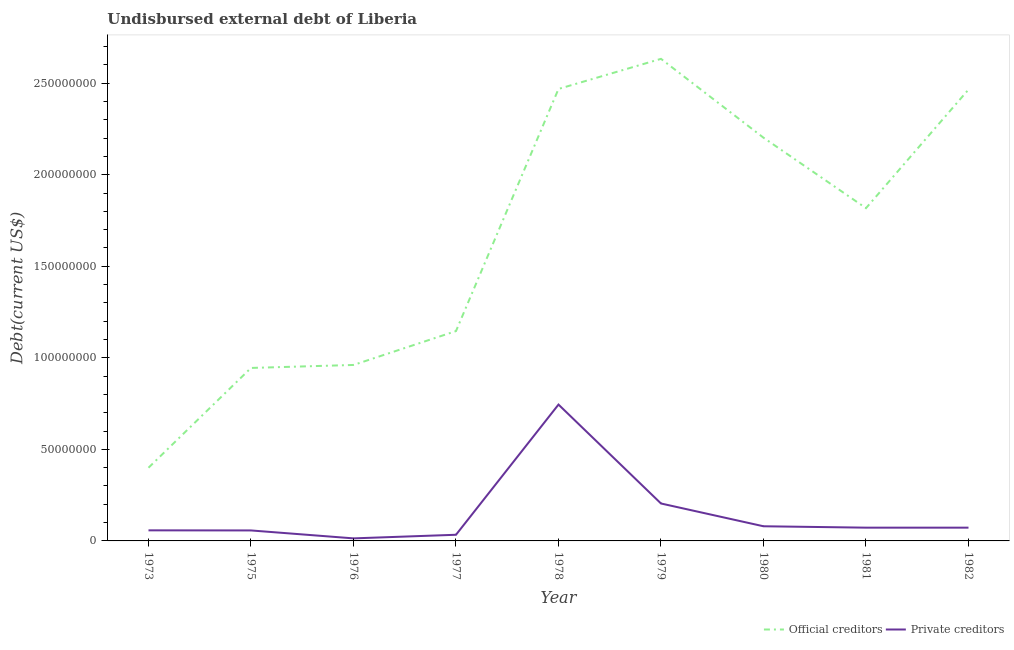How many different coloured lines are there?
Make the answer very short. 2. Does the line corresponding to undisbursed external debt of private creditors intersect with the line corresponding to undisbursed external debt of official creditors?
Ensure brevity in your answer.  No. Is the number of lines equal to the number of legend labels?
Provide a succinct answer. Yes. What is the undisbursed external debt of private creditors in 1981?
Your answer should be very brief. 7.24e+06. Across all years, what is the maximum undisbursed external debt of official creditors?
Your answer should be very brief. 2.63e+08. Across all years, what is the minimum undisbursed external debt of official creditors?
Provide a short and direct response. 4.00e+07. In which year was the undisbursed external debt of official creditors maximum?
Ensure brevity in your answer.  1979. In which year was the undisbursed external debt of private creditors minimum?
Keep it short and to the point. 1976. What is the total undisbursed external debt of private creditors in the graph?
Your answer should be very brief. 1.34e+08. What is the difference between the undisbursed external debt of private creditors in 1978 and that in 1982?
Provide a short and direct response. 6.72e+07. What is the difference between the undisbursed external debt of private creditors in 1981 and the undisbursed external debt of official creditors in 1977?
Ensure brevity in your answer.  -1.07e+08. What is the average undisbursed external debt of official creditors per year?
Your response must be concise. 1.67e+08. In the year 1982, what is the difference between the undisbursed external debt of private creditors and undisbursed external debt of official creditors?
Your answer should be compact. -2.39e+08. In how many years, is the undisbursed external debt of official creditors greater than 100000000 US$?
Make the answer very short. 6. What is the ratio of the undisbursed external debt of official creditors in 1979 to that in 1982?
Your answer should be very brief. 1.07. Is the difference between the undisbursed external debt of official creditors in 1977 and 1981 greater than the difference between the undisbursed external debt of private creditors in 1977 and 1981?
Keep it short and to the point. No. What is the difference between the highest and the second highest undisbursed external debt of private creditors?
Give a very brief answer. 5.40e+07. What is the difference between the highest and the lowest undisbursed external debt of private creditors?
Your answer should be very brief. 7.31e+07. Is the sum of the undisbursed external debt of official creditors in 1975 and 1977 greater than the maximum undisbursed external debt of private creditors across all years?
Ensure brevity in your answer.  Yes. Does the undisbursed external debt of private creditors monotonically increase over the years?
Offer a very short reply. No. Is the undisbursed external debt of official creditors strictly less than the undisbursed external debt of private creditors over the years?
Make the answer very short. No. How many years are there in the graph?
Offer a terse response. 9. What is the difference between two consecutive major ticks on the Y-axis?
Ensure brevity in your answer.  5.00e+07. Does the graph contain grids?
Make the answer very short. No. Where does the legend appear in the graph?
Your answer should be very brief. Bottom right. How many legend labels are there?
Provide a succinct answer. 2. What is the title of the graph?
Provide a short and direct response. Undisbursed external debt of Liberia. What is the label or title of the X-axis?
Keep it short and to the point. Year. What is the label or title of the Y-axis?
Offer a very short reply. Debt(current US$). What is the Debt(current US$) of Official creditors in 1973?
Offer a terse response. 4.00e+07. What is the Debt(current US$) in Private creditors in 1973?
Ensure brevity in your answer.  5.78e+06. What is the Debt(current US$) in Official creditors in 1975?
Your answer should be compact. 9.45e+07. What is the Debt(current US$) of Private creditors in 1975?
Provide a short and direct response. 5.72e+06. What is the Debt(current US$) in Official creditors in 1976?
Your response must be concise. 9.61e+07. What is the Debt(current US$) in Private creditors in 1976?
Offer a terse response. 1.39e+06. What is the Debt(current US$) of Official creditors in 1977?
Make the answer very short. 1.15e+08. What is the Debt(current US$) in Private creditors in 1977?
Provide a short and direct response. 3.36e+06. What is the Debt(current US$) in Official creditors in 1978?
Your answer should be compact. 2.47e+08. What is the Debt(current US$) of Private creditors in 1978?
Make the answer very short. 7.45e+07. What is the Debt(current US$) of Official creditors in 1979?
Ensure brevity in your answer.  2.63e+08. What is the Debt(current US$) in Private creditors in 1979?
Your answer should be very brief. 2.04e+07. What is the Debt(current US$) of Official creditors in 1980?
Make the answer very short. 2.20e+08. What is the Debt(current US$) of Official creditors in 1981?
Ensure brevity in your answer.  1.82e+08. What is the Debt(current US$) in Private creditors in 1981?
Offer a very short reply. 7.24e+06. What is the Debt(current US$) of Official creditors in 1982?
Provide a short and direct response. 2.46e+08. What is the Debt(current US$) in Private creditors in 1982?
Give a very brief answer. 7.24e+06. Across all years, what is the maximum Debt(current US$) in Official creditors?
Ensure brevity in your answer.  2.63e+08. Across all years, what is the maximum Debt(current US$) in Private creditors?
Offer a very short reply. 7.45e+07. Across all years, what is the minimum Debt(current US$) of Official creditors?
Make the answer very short. 4.00e+07. Across all years, what is the minimum Debt(current US$) of Private creditors?
Your answer should be very brief. 1.39e+06. What is the total Debt(current US$) of Official creditors in the graph?
Offer a very short reply. 1.50e+09. What is the total Debt(current US$) in Private creditors in the graph?
Provide a succinct answer. 1.34e+08. What is the difference between the Debt(current US$) of Official creditors in 1973 and that in 1975?
Provide a succinct answer. -5.45e+07. What is the difference between the Debt(current US$) in Private creditors in 1973 and that in 1975?
Your answer should be very brief. 5.30e+04. What is the difference between the Debt(current US$) of Official creditors in 1973 and that in 1976?
Offer a very short reply. -5.61e+07. What is the difference between the Debt(current US$) of Private creditors in 1973 and that in 1976?
Offer a terse response. 4.38e+06. What is the difference between the Debt(current US$) of Official creditors in 1973 and that in 1977?
Give a very brief answer. -7.46e+07. What is the difference between the Debt(current US$) in Private creditors in 1973 and that in 1977?
Provide a short and direct response. 2.42e+06. What is the difference between the Debt(current US$) of Official creditors in 1973 and that in 1978?
Keep it short and to the point. -2.07e+08. What is the difference between the Debt(current US$) of Private creditors in 1973 and that in 1978?
Your answer should be very brief. -6.87e+07. What is the difference between the Debt(current US$) of Official creditors in 1973 and that in 1979?
Offer a very short reply. -2.23e+08. What is the difference between the Debt(current US$) in Private creditors in 1973 and that in 1979?
Provide a succinct answer. -1.47e+07. What is the difference between the Debt(current US$) of Official creditors in 1973 and that in 1980?
Offer a terse response. -1.80e+08. What is the difference between the Debt(current US$) of Private creditors in 1973 and that in 1980?
Offer a very short reply. -2.22e+06. What is the difference between the Debt(current US$) of Official creditors in 1973 and that in 1981?
Your answer should be compact. -1.42e+08. What is the difference between the Debt(current US$) in Private creditors in 1973 and that in 1981?
Your answer should be very brief. -1.47e+06. What is the difference between the Debt(current US$) in Official creditors in 1973 and that in 1982?
Your response must be concise. -2.07e+08. What is the difference between the Debt(current US$) of Private creditors in 1973 and that in 1982?
Provide a short and direct response. -1.47e+06. What is the difference between the Debt(current US$) in Official creditors in 1975 and that in 1976?
Make the answer very short. -1.63e+06. What is the difference between the Debt(current US$) of Private creditors in 1975 and that in 1976?
Your response must be concise. 4.33e+06. What is the difference between the Debt(current US$) of Official creditors in 1975 and that in 1977?
Your response must be concise. -2.01e+07. What is the difference between the Debt(current US$) in Private creditors in 1975 and that in 1977?
Offer a very short reply. 2.36e+06. What is the difference between the Debt(current US$) in Official creditors in 1975 and that in 1978?
Make the answer very short. -1.52e+08. What is the difference between the Debt(current US$) of Private creditors in 1975 and that in 1978?
Give a very brief answer. -6.87e+07. What is the difference between the Debt(current US$) in Official creditors in 1975 and that in 1979?
Make the answer very short. -1.69e+08. What is the difference between the Debt(current US$) in Private creditors in 1975 and that in 1979?
Your answer should be compact. -1.47e+07. What is the difference between the Debt(current US$) of Official creditors in 1975 and that in 1980?
Provide a succinct answer. -1.26e+08. What is the difference between the Debt(current US$) in Private creditors in 1975 and that in 1980?
Make the answer very short. -2.28e+06. What is the difference between the Debt(current US$) in Official creditors in 1975 and that in 1981?
Your response must be concise. -8.73e+07. What is the difference between the Debt(current US$) in Private creditors in 1975 and that in 1981?
Your response must be concise. -1.52e+06. What is the difference between the Debt(current US$) in Official creditors in 1975 and that in 1982?
Your answer should be very brief. -1.52e+08. What is the difference between the Debt(current US$) of Private creditors in 1975 and that in 1982?
Provide a short and direct response. -1.52e+06. What is the difference between the Debt(current US$) in Official creditors in 1976 and that in 1977?
Ensure brevity in your answer.  -1.85e+07. What is the difference between the Debt(current US$) of Private creditors in 1976 and that in 1977?
Offer a terse response. -1.97e+06. What is the difference between the Debt(current US$) in Official creditors in 1976 and that in 1978?
Your answer should be compact. -1.51e+08. What is the difference between the Debt(current US$) in Private creditors in 1976 and that in 1978?
Keep it short and to the point. -7.31e+07. What is the difference between the Debt(current US$) of Official creditors in 1976 and that in 1979?
Keep it short and to the point. -1.67e+08. What is the difference between the Debt(current US$) of Private creditors in 1976 and that in 1979?
Give a very brief answer. -1.90e+07. What is the difference between the Debt(current US$) of Official creditors in 1976 and that in 1980?
Your answer should be compact. -1.24e+08. What is the difference between the Debt(current US$) in Private creditors in 1976 and that in 1980?
Your answer should be very brief. -6.61e+06. What is the difference between the Debt(current US$) in Official creditors in 1976 and that in 1981?
Your answer should be compact. -8.56e+07. What is the difference between the Debt(current US$) of Private creditors in 1976 and that in 1981?
Your answer should be compact. -5.85e+06. What is the difference between the Debt(current US$) of Official creditors in 1976 and that in 1982?
Provide a succinct answer. -1.50e+08. What is the difference between the Debt(current US$) of Private creditors in 1976 and that in 1982?
Your response must be concise. -5.85e+06. What is the difference between the Debt(current US$) in Official creditors in 1977 and that in 1978?
Your answer should be compact. -1.32e+08. What is the difference between the Debt(current US$) in Private creditors in 1977 and that in 1978?
Offer a terse response. -7.11e+07. What is the difference between the Debt(current US$) of Official creditors in 1977 and that in 1979?
Keep it short and to the point. -1.49e+08. What is the difference between the Debt(current US$) of Private creditors in 1977 and that in 1979?
Provide a succinct answer. -1.71e+07. What is the difference between the Debt(current US$) in Official creditors in 1977 and that in 1980?
Provide a short and direct response. -1.06e+08. What is the difference between the Debt(current US$) in Private creditors in 1977 and that in 1980?
Give a very brief answer. -4.64e+06. What is the difference between the Debt(current US$) in Official creditors in 1977 and that in 1981?
Make the answer very short. -6.71e+07. What is the difference between the Debt(current US$) of Private creditors in 1977 and that in 1981?
Provide a short and direct response. -3.88e+06. What is the difference between the Debt(current US$) of Official creditors in 1977 and that in 1982?
Make the answer very short. -1.32e+08. What is the difference between the Debt(current US$) in Private creditors in 1977 and that in 1982?
Your answer should be very brief. -3.88e+06. What is the difference between the Debt(current US$) of Official creditors in 1978 and that in 1979?
Ensure brevity in your answer.  -1.64e+07. What is the difference between the Debt(current US$) in Private creditors in 1978 and that in 1979?
Provide a succinct answer. 5.40e+07. What is the difference between the Debt(current US$) of Official creditors in 1978 and that in 1980?
Your answer should be compact. 2.66e+07. What is the difference between the Debt(current US$) of Private creditors in 1978 and that in 1980?
Your answer should be very brief. 6.65e+07. What is the difference between the Debt(current US$) in Official creditors in 1978 and that in 1981?
Provide a short and direct response. 6.51e+07. What is the difference between the Debt(current US$) of Private creditors in 1978 and that in 1981?
Your answer should be very brief. 6.72e+07. What is the difference between the Debt(current US$) in Official creditors in 1978 and that in 1982?
Provide a succinct answer. 3.36e+05. What is the difference between the Debt(current US$) of Private creditors in 1978 and that in 1982?
Your response must be concise. 6.72e+07. What is the difference between the Debt(current US$) of Official creditors in 1979 and that in 1980?
Your response must be concise. 4.31e+07. What is the difference between the Debt(current US$) in Private creditors in 1979 and that in 1980?
Provide a short and direct response. 1.24e+07. What is the difference between the Debt(current US$) in Official creditors in 1979 and that in 1981?
Provide a succinct answer. 8.15e+07. What is the difference between the Debt(current US$) in Private creditors in 1979 and that in 1981?
Offer a terse response. 1.32e+07. What is the difference between the Debt(current US$) in Official creditors in 1979 and that in 1982?
Provide a short and direct response. 1.68e+07. What is the difference between the Debt(current US$) of Private creditors in 1979 and that in 1982?
Offer a very short reply. 1.32e+07. What is the difference between the Debt(current US$) in Official creditors in 1980 and that in 1981?
Offer a terse response. 3.85e+07. What is the difference between the Debt(current US$) of Private creditors in 1980 and that in 1981?
Provide a short and direct response. 7.58e+05. What is the difference between the Debt(current US$) of Official creditors in 1980 and that in 1982?
Make the answer very short. -2.63e+07. What is the difference between the Debt(current US$) in Private creditors in 1980 and that in 1982?
Ensure brevity in your answer.  7.58e+05. What is the difference between the Debt(current US$) in Official creditors in 1981 and that in 1982?
Your response must be concise. -6.48e+07. What is the difference between the Debt(current US$) of Official creditors in 1973 and the Debt(current US$) of Private creditors in 1975?
Ensure brevity in your answer.  3.42e+07. What is the difference between the Debt(current US$) of Official creditors in 1973 and the Debt(current US$) of Private creditors in 1976?
Provide a succinct answer. 3.86e+07. What is the difference between the Debt(current US$) of Official creditors in 1973 and the Debt(current US$) of Private creditors in 1977?
Offer a terse response. 3.66e+07. What is the difference between the Debt(current US$) of Official creditors in 1973 and the Debt(current US$) of Private creditors in 1978?
Provide a succinct answer. -3.45e+07. What is the difference between the Debt(current US$) in Official creditors in 1973 and the Debt(current US$) in Private creditors in 1979?
Your answer should be compact. 1.95e+07. What is the difference between the Debt(current US$) in Official creditors in 1973 and the Debt(current US$) in Private creditors in 1980?
Give a very brief answer. 3.20e+07. What is the difference between the Debt(current US$) of Official creditors in 1973 and the Debt(current US$) of Private creditors in 1981?
Your response must be concise. 3.27e+07. What is the difference between the Debt(current US$) of Official creditors in 1973 and the Debt(current US$) of Private creditors in 1982?
Provide a succinct answer. 3.27e+07. What is the difference between the Debt(current US$) of Official creditors in 1975 and the Debt(current US$) of Private creditors in 1976?
Your response must be concise. 9.31e+07. What is the difference between the Debt(current US$) in Official creditors in 1975 and the Debt(current US$) in Private creditors in 1977?
Ensure brevity in your answer.  9.11e+07. What is the difference between the Debt(current US$) of Official creditors in 1975 and the Debt(current US$) of Private creditors in 1978?
Make the answer very short. 2.00e+07. What is the difference between the Debt(current US$) of Official creditors in 1975 and the Debt(current US$) of Private creditors in 1979?
Your answer should be very brief. 7.40e+07. What is the difference between the Debt(current US$) in Official creditors in 1975 and the Debt(current US$) in Private creditors in 1980?
Offer a very short reply. 8.65e+07. What is the difference between the Debt(current US$) in Official creditors in 1975 and the Debt(current US$) in Private creditors in 1981?
Provide a short and direct response. 8.72e+07. What is the difference between the Debt(current US$) in Official creditors in 1975 and the Debt(current US$) in Private creditors in 1982?
Your answer should be compact. 8.72e+07. What is the difference between the Debt(current US$) in Official creditors in 1976 and the Debt(current US$) in Private creditors in 1977?
Your answer should be compact. 9.27e+07. What is the difference between the Debt(current US$) in Official creditors in 1976 and the Debt(current US$) in Private creditors in 1978?
Offer a very short reply. 2.16e+07. What is the difference between the Debt(current US$) in Official creditors in 1976 and the Debt(current US$) in Private creditors in 1979?
Ensure brevity in your answer.  7.57e+07. What is the difference between the Debt(current US$) in Official creditors in 1976 and the Debt(current US$) in Private creditors in 1980?
Offer a very short reply. 8.81e+07. What is the difference between the Debt(current US$) of Official creditors in 1976 and the Debt(current US$) of Private creditors in 1981?
Your answer should be compact. 8.89e+07. What is the difference between the Debt(current US$) of Official creditors in 1976 and the Debt(current US$) of Private creditors in 1982?
Your answer should be compact. 8.89e+07. What is the difference between the Debt(current US$) of Official creditors in 1977 and the Debt(current US$) of Private creditors in 1978?
Ensure brevity in your answer.  4.01e+07. What is the difference between the Debt(current US$) in Official creditors in 1977 and the Debt(current US$) in Private creditors in 1979?
Your answer should be compact. 9.42e+07. What is the difference between the Debt(current US$) of Official creditors in 1977 and the Debt(current US$) of Private creditors in 1980?
Provide a succinct answer. 1.07e+08. What is the difference between the Debt(current US$) of Official creditors in 1977 and the Debt(current US$) of Private creditors in 1981?
Your answer should be very brief. 1.07e+08. What is the difference between the Debt(current US$) of Official creditors in 1977 and the Debt(current US$) of Private creditors in 1982?
Provide a succinct answer. 1.07e+08. What is the difference between the Debt(current US$) in Official creditors in 1978 and the Debt(current US$) in Private creditors in 1979?
Offer a very short reply. 2.26e+08. What is the difference between the Debt(current US$) in Official creditors in 1978 and the Debt(current US$) in Private creditors in 1980?
Offer a very short reply. 2.39e+08. What is the difference between the Debt(current US$) in Official creditors in 1978 and the Debt(current US$) in Private creditors in 1981?
Provide a short and direct response. 2.40e+08. What is the difference between the Debt(current US$) of Official creditors in 1978 and the Debt(current US$) of Private creditors in 1982?
Ensure brevity in your answer.  2.40e+08. What is the difference between the Debt(current US$) of Official creditors in 1979 and the Debt(current US$) of Private creditors in 1980?
Offer a terse response. 2.55e+08. What is the difference between the Debt(current US$) in Official creditors in 1979 and the Debt(current US$) in Private creditors in 1981?
Give a very brief answer. 2.56e+08. What is the difference between the Debt(current US$) of Official creditors in 1979 and the Debt(current US$) of Private creditors in 1982?
Keep it short and to the point. 2.56e+08. What is the difference between the Debt(current US$) in Official creditors in 1980 and the Debt(current US$) in Private creditors in 1981?
Keep it short and to the point. 2.13e+08. What is the difference between the Debt(current US$) in Official creditors in 1980 and the Debt(current US$) in Private creditors in 1982?
Your answer should be very brief. 2.13e+08. What is the difference between the Debt(current US$) in Official creditors in 1981 and the Debt(current US$) in Private creditors in 1982?
Provide a short and direct response. 1.74e+08. What is the average Debt(current US$) in Official creditors per year?
Make the answer very short. 1.67e+08. What is the average Debt(current US$) of Private creditors per year?
Ensure brevity in your answer.  1.48e+07. In the year 1973, what is the difference between the Debt(current US$) of Official creditors and Debt(current US$) of Private creditors?
Ensure brevity in your answer.  3.42e+07. In the year 1975, what is the difference between the Debt(current US$) in Official creditors and Debt(current US$) in Private creditors?
Ensure brevity in your answer.  8.87e+07. In the year 1976, what is the difference between the Debt(current US$) of Official creditors and Debt(current US$) of Private creditors?
Keep it short and to the point. 9.47e+07. In the year 1977, what is the difference between the Debt(current US$) of Official creditors and Debt(current US$) of Private creditors?
Your response must be concise. 1.11e+08. In the year 1978, what is the difference between the Debt(current US$) in Official creditors and Debt(current US$) in Private creditors?
Offer a very short reply. 1.72e+08. In the year 1979, what is the difference between the Debt(current US$) in Official creditors and Debt(current US$) in Private creditors?
Offer a very short reply. 2.43e+08. In the year 1980, what is the difference between the Debt(current US$) in Official creditors and Debt(current US$) in Private creditors?
Offer a terse response. 2.12e+08. In the year 1981, what is the difference between the Debt(current US$) in Official creditors and Debt(current US$) in Private creditors?
Keep it short and to the point. 1.74e+08. In the year 1982, what is the difference between the Debt(current US$) of Official creditors and Debt(current US$) of Private creditors?
Your response must be concise. 2.39e+08. What is the ratio of the Debt(current US$) of Official creditors in 1973 to that in 1975?
Your answer should be compact. 0.42. What is the ratio of the Debt(current US$) in Private creditors in 1973 to that in 1975?
Your answer should be very brief. 1.01. What is the ratio of the Debt(current US$) in Official creditors in 1973 to that in 1976?
Provide a short and direct response. 0.42. What is the ratio of the Debt(current US$) in Private creditors in 1973 to that in 1976?
Offer a very short reply. 4.15. What is the ratio of the Debt(current US$) in Official creditors in 1973 to that in 1977?
Make the answer very short. 0.35. What is the ratio of the Debt(current US$) of Private creditors in 1973 to that in 1977?
Give a very brief answer. 1.72. What is the ratio of the Debt(current US$) of Official creditors in 1973 to that in 1978?
Offer a very short reply. 0.16. What is the ratio of the Debt(current US$) of Private creditors in 1973 to that in 1978?
Your answer should be very brief. 0.08. What is the ratio of the Debt(current US$) of Official creditors in 1973 to that in 1979?
Give a very brief answer. 0.15. What is the ratio of the Debt(current US$) of Private creditors in 1973 to that in 1979?
Keep it short and to the point. 0.28. What is the ratio of the Debt(current US$) in Official creditors in 1973 to that in 1980?
Give a very brief answer. 0.18. What is the ratio of the Debt(current US$) of Private creditors in 1973 to that in 1980?
Provide a short and direct response. 0.72. What is the ratio of the Debt(current US$) of Official creditors in 1973 to that in 1981?
Give a very brief answer. 0.22. What is the ratio of the Debt(current US$) of Private creditors in 1973 to that in 1981?
Your response must be concise. 0.8. What is the ratio of the Debt(current US$) in Official creditors in 1973 to that in 1982?
Your answer should be very brief. 0.16. What is the ratio of the Debt(current US$) of Private creditors in 1973 to that in 1982?
Provide a short and direct response. 0.8. What is the ratio of the Debt(current US$) in Official creditors in 1975 to that in 1976?
Your answer should be compact. 0.98. What is the ratio of the Debt(current US$) in Private creditors in 1975 to that in 1976?
Keep it short and to the point. 4.11. What is the ratio of the Debt(current US$) of Official creditors in 1975 to that in 1977?
Your answer should be compact. 0.82. What is the ratio of the Debt(current US$) of Private creditors in 1975 to that in 1977?
Give a very brief answer. 1.7. What is the ratio of the Debt(current US$) in Official creditors in 1975 to that in 1978?
Provide a short and direct response. 0.38. What is the ratio of the Debt(current US$) of Private creditors in 1975 to that in 1978?
Provide a short and direct response. 0.08. What is the ratio of the Debt(current US$) of Official creditors in 1975 to that in 1979?
Provide a succinct answer. 0.36. What is the ratio of the Debt(current US$) of Private creditors in 1975 to that in 1979?
Ensure brevity in your answer.  0.28. What is the ratio of the Debt(current US$) in Official creditors in 1975 to that in 1980?
Your answer should be compact. 0.43. What is the ratio of the Debt(current US$) in Private creditors in 1975 to that in 1980?
Give a very brief answer. 0.72. What is the ratio of the Debt(current US$) in Official creditors in 1975 to that in 1981?
Provide a short and direct response. 0.52. What is the ratio of the Debt(current US$) of Private creditors in 1975 to that in 1981?
Offer a very short reply. 0.79. What is the ratio of the Debt(current US$) of Official creditors in 1975 to that in 1982?
Your answer should be compact. 0.38. What is the ratio of the Debt(current US$) in Private creditors in 1975 to that in 1982?
Ensure brevity in your answer.  0.79. What is the ratio of the Debt(current US$) in Official creditors in 1976 to that in 1977?
Ensure brevity in your answer.  0.84. What is the ratio of the Debt(current US$) in Private creditors in 1976 to that in 1977?
Your answer should be compact. 0.41. What is the ratio of the Debt(current US$) in Official creditors in 1976 to that in 1978?
Keep it short and to the point. 0.39. What is the ratio of the Debt(current US$) in Private creditors in 1976 to that in 1978?
Provide a short and direct response. 0.02. What is the ratio of the Debt(current US$) of Official creditors in 1976 to that in 1979?
Offer a terse response. 0.36. What is the ratio of the Debt(current US$) of Private creditors in 1976 to that in 1979?
Your answer should be compact. 0.07. What is the ratio of the Debt(current US$) of Official creditors in 1976 to that in 1980?
Offer a very short reply. 0.44. What is the ratio of the Debt(current US$) of Private creditors in 1976 to that in 1980?
Keep it short and to the point. 0.17. What is the ratio of the Debt(current US$) in Official creditors in 1976 to that in 1981?
Keep it short and to the point. 0.53. What is the ratio of the Debt(current US$) in Private creditors in 1976 to that in 1981?
Make the answer very short. 0.19. What is the ratio of the Debt(current US$) of Official creditors in 1976 to that in 1982?
Ensure brevity in your answer.  0.39. What is the ratio of the Debt(current US$) in Private creditors in 1976 to that in 1982?
Give a very brief answer. 0.19. What is the ratio of the Debt(current US$) of Official creditors in 1977 to that in 1978?
Make the answer very short. 0.46. What is the ratio of the Debt(current US$) of Private creditors in 1977 to that in 1978?
Give a very brief answer. 0.05. What is the ratio of the Debt(current US$) in Official creditors in 1977 to that in 1979?
Your response must be concise. 0.44. What is the ratio of the Debt(current US$) of Private creditors in 1977 to that in 1979?
Keep it short and to the point. 0.16. What is the ratio of the Debt(current US$) of Official creditors in 1977 to that in 1980?
Provide a succinct answer. 0.52. What is the ratio of the Debt(current US$) of Private creditors in 1977 to that in 1980?
Ensure brevity in your answer.  0.42. What is the ratio of the Debt(current US$) of Official creditors in 1977 to that in 1981?
Give a very brief answer. 0.63. What is the ratio of the Debt(current US$) in Private creditors in 1977 to that in 1981?
Offer a terse response. 0.46. What is the ratio of the Debt(current US$) in Official creditors in 1977 to that in 1982?
Provide a succinct answer. 0.46. What is the ratio of the Debt(current US$) of Private creditors in 1977 to that in 1982?
Offer a very short reply. 0.46. What is the ratio of the Debt(current US$) in Official creditors in 1978 to that in 1979?
Ensure brevity in your answer.  0.94. What is the ratio of the Debt(current US$) in Private creditors in 1978 to that in 1979?
Offer a very short reply. 3.64. What is the ratio of the Debt(current US$) in Official creditors in 1978 to that in 1980?
Make the answer very short. 1.12. What is the ratio of the Debt(current US$) in Private creditors in 1978 to that in 1980?
Your response must be concise. 9.31. What is the ratio of the Debt(current US$) of Official creditors in 1978 to that in 1981?
Offer a very short reply. 1.36. What is the ratio of the Debt(current US$) of Private creditors in 1978 to that in 1981?
Your response must be concise. 10.28. What is the ratio of the Debt(current US$) of Official creditors in 1978 to that in 1982?
Give a very brief answer. 1. What is the ratio of the Debt(current US$) of Private creditors in 1978 to that in 1982?
Offer a terse response. 10.28. What is the ratio of the Debt(current US$) of Official creditors in 1979 to that in 1980?
Offer a terse response. 1.2. What is the ratio of the Debt(current US$) of Private creditors in 1979 to that in 1980?
Ensure brevity in your answer.  2.55. What is the ratio of the Debt(current US$) of Official creditors in 1979 to that in 1981?
Ensure brevity in your answer.  1.45. What is the ratio of the Debt(current US$) in Private creditors in 1979 to that in 1981?
Provide a succinct answer. 2.82. What is the ratio of the Debt(current US$) of Official creditors in 1979 to that in 1982?
Your answer should be very brief. 1.07. What is the ratio of the Debt(current US$) of Private creditors in 1979 to that in 1982?
Provide a short and direct response. 2.82. What is the ratio of the Debt(current US$) in Official creditors in 1980 to that in 1981?
Provide a succinct answer. 1.21. What is the ratio of the Debt(current US$) in Private creditors in 1980 to that in 1981?
Your answer should be compact. 1.1. What is the ratio of the Debt(current US$) in Official creditors in 1980 to that in 1982?
Ensure brevity in your answer.  0.89. What is the ratio of the Debt(current US$) of Private creditors in 1980 to that in 1982?
Offer a terse response. 1.1. What is the ratio of the Debt(current US$) of Official creditors in 1981 to that in 1982?
Offer a terse response. 0.74. What is the difference between the highest and the second highest Debt(current US$) in Official creditors?
Your response must be concise. 1.64e+07. What is the difference between the highest and the second highest Debt(current US$) of Private creditors?
Your answer should be very brief. 5.40e+07. What is the difference between the highest and the lowest Debt(current US$) of Official creditors?
Your answer should be very brief. 2.23e+08. What is the difference between the highest and the lowest Debt(current US$) in Private creditors?
Your answer should be compact. 7.31e+07. 